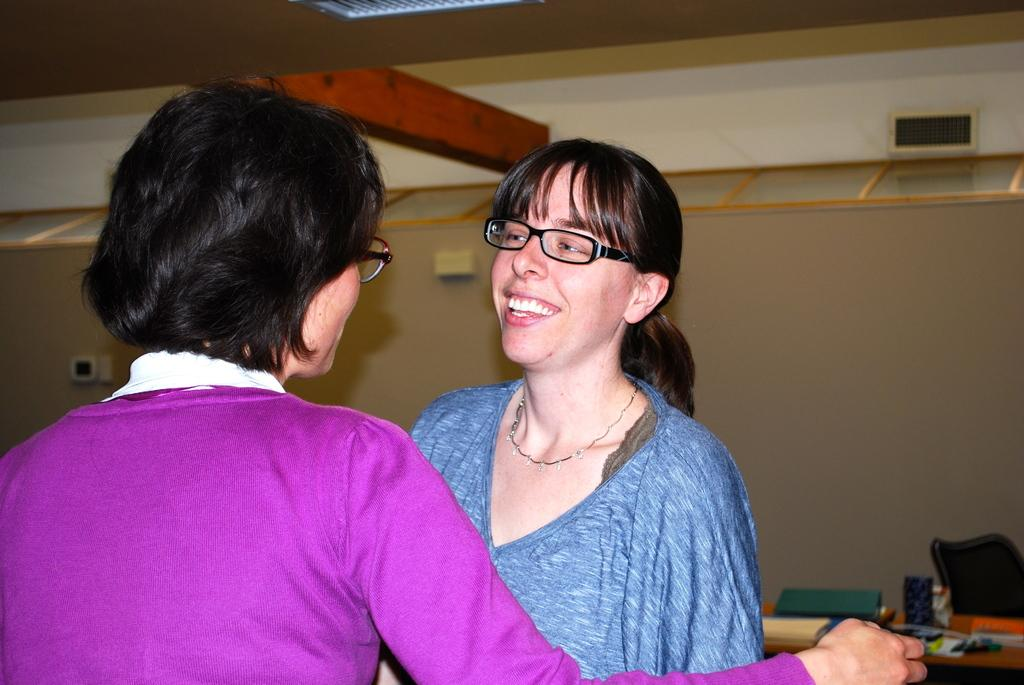How many people are in the image? There are two ladies in the image. What are the ladies wearing that is noticeable? The ladies are wearing glasses (specs) in the image. What can be seen in the background of the image? There is a wall in the background of the image. What is on the right side of the image? There is a table with items on the right side of the image. What type of bomb is being diffused by the ladies in the image? There is no bomb present in the image; it features two ladies wearing glasses and a table with items. 